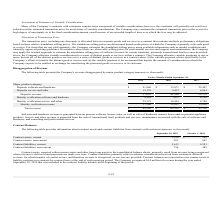According to Mitek Systems's financial document, How is software and hardware revenue generated from? on premise software license sales, as well as sales of hardware scanner boxes and on premise appliance products. The document states: "Software and hardware revenue is generated from on premise software license sales, as well as sales of hardware scanner boxes and on premise appliance..." Also, What is the value of Deposits software and hardware in fiscal 2019? According to the financial document, $41,860 (in thousands). The relevant text states: "Deposits software and hardware $ 41,860 $ 33,071 $ 25,407..." Also, What is the total revenue in the fiscal year 2018? According to the financial document, $63,559 (in thousands). The relevant text states: "Total revenue $ 84,590 $ 63,559 $ 45,390..." Also, can you calculate: What is the average of the Company’s total revenue from 2017 to 2019? To answer this question, I need to perform calculations using the financial data. The calculation is: (45,390+63,559+84,590)/3 , which equals 64513 (in thousands). This is based on the information: "Total revenue $ 84,590 $ 63,559 $ 45,390 Total revenue $ 84,590 $ 63,559 $ 45,390 Total revenue $ 84,590 $ 63,559 $ 45,390..." The key data points involved are: 45,390, 63,559, 84,590. Also, can you calculate: What is the proportion of deposits revenue over total revenue in 2017? Based on the calculation: 32,370/45,390 , the result is 0.71. This is based on the information: "Deposits revenue 57,030 41,508 32,370 Total revenue $ 84,590 $ 63,559 $ 45,390..." The key data points involved are: 32,370, 45,390. Additionally, Which year had the greatest amount of total revenue? According to the financial document, 2019. The relevant text states: "2019 2018 2017..." 